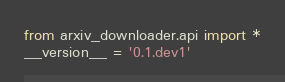Convert code to text. <code><loc_0><loc_0><loc_500><loc_500><_Python_>from arxiv_downloader.api import *
__version__ = '0.1.dev1'</code> 